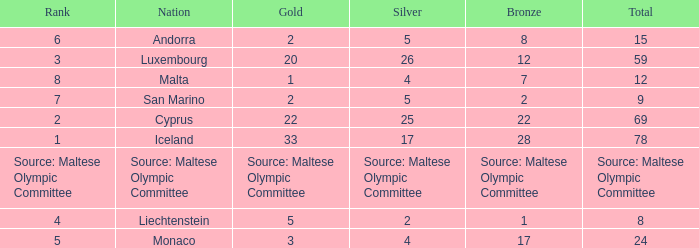What nation has 28 bronze medals? Iceland. 